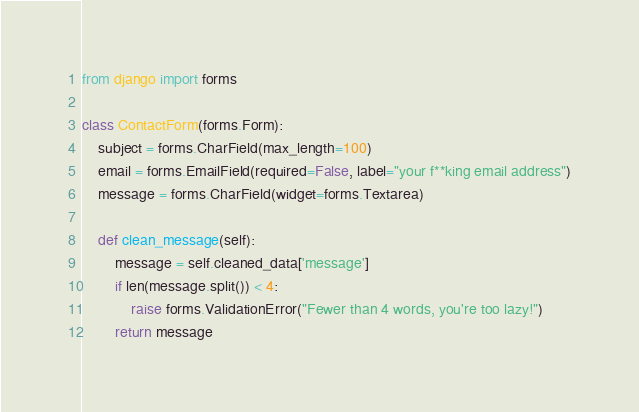<code> <loc_0><loc_0><loc_500><loc_500><_Python_>from django import forms

class ContactForm(forms.Form):
    subject = forms.CharField(max_length=100)
    email = forms.EmailField(required=False, label="your f**king email address")
    message = forms.CharField(widget=forms.Textarea)

    def clean_message(self):
        message = self.cleaned_data['message']
        if len(message.split()) < 4:
            raise forms.ValidationError("Fewer than 4 words, you're too lazy!")
        return message
</code> 